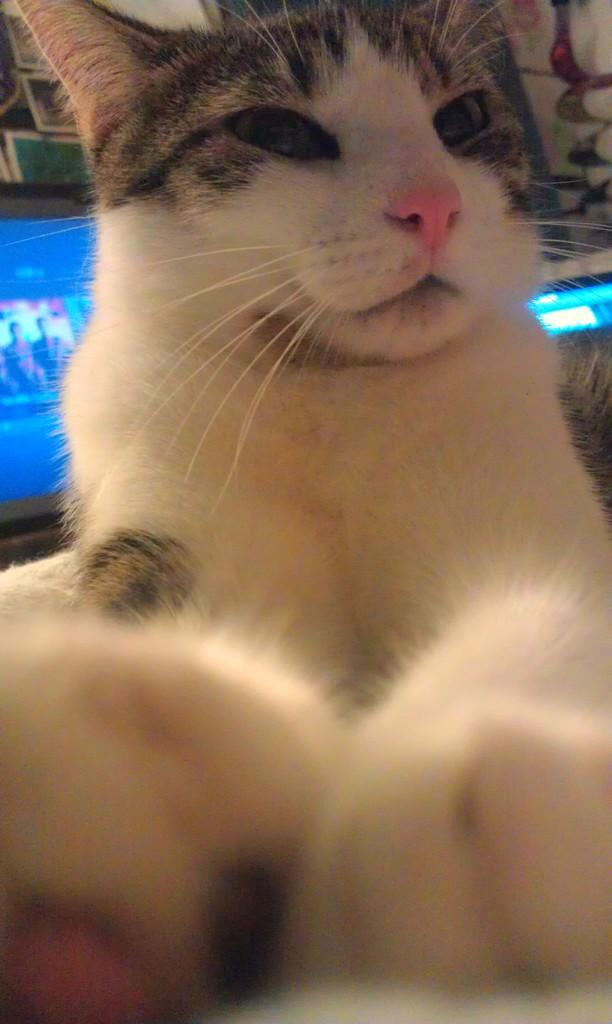What type of animal is in the image? There is a cat in the image. What electronic devices are visible in the image? There are television screens in the back of the image. Where are the television screens located in relation to the wall? The television screens are near a wall. What can be found in the top left corner of the image? There is a wooden rack in the top left corner of the image. What is on the wooden rack? There are frames on the wooden rack. What type of soup is being served on the television screens? There is no soup present in the image; the television screens are electronic devices. 